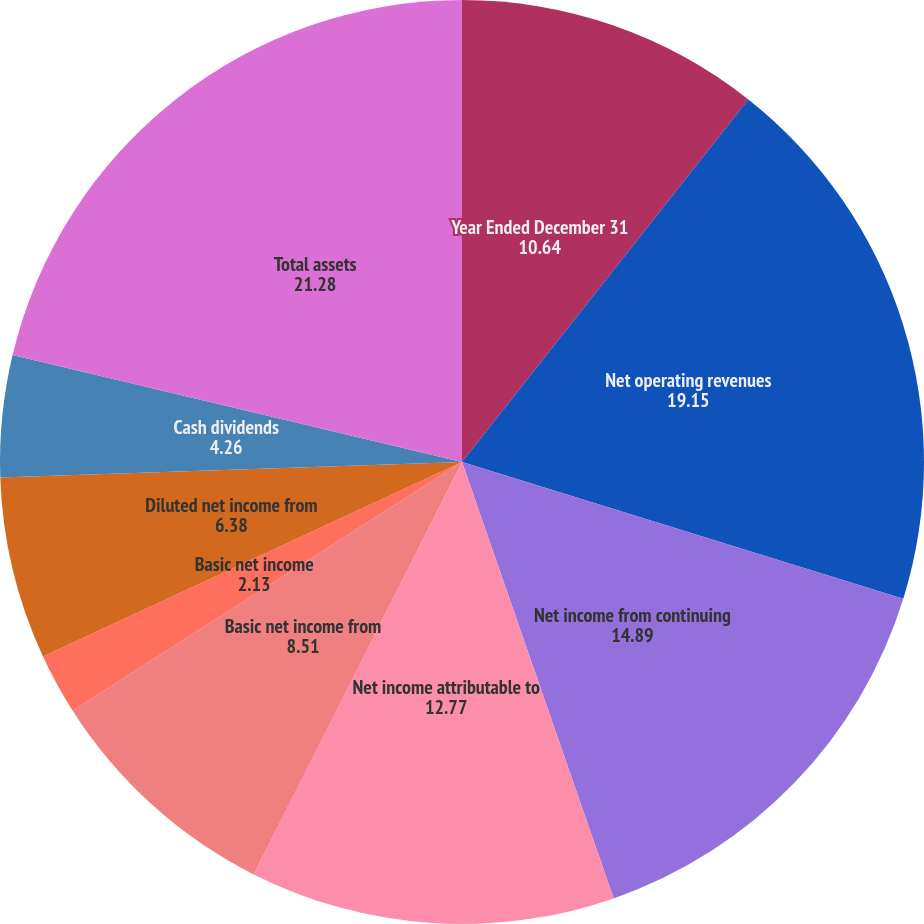<chart> <loc_0><loc_0><loc_500><loc_500><pie_chart><fcel>Year Ended December 31<fcel>Net operating revenues<fcel>Net income from continuing<fcel>Net income attributable to<fcel>Basic net income from<fcel>Basic net income<fcel>Diluted net income from<fcel>Diluted net income<fcel>Cash dividends<fcel>Total assets<nl><fcel>10.64%<fcel>19.15%<fcel>14.89%<fcel>12.77%<fcel>8.51%<fcel>2.13%<fcel>6.38%<fcel>0.0%<fcel>4.26%<fcel>21.28%<nl></chart> 